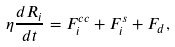<formula> <loc_0><loc_0><loc_500><loc_500>\eta \frac { d { R } _ { i } } { d t } = { F } ^ { c c } _ { i } + { F } ^ { s } _ { i } + { F } _ { d } ,</formula> 